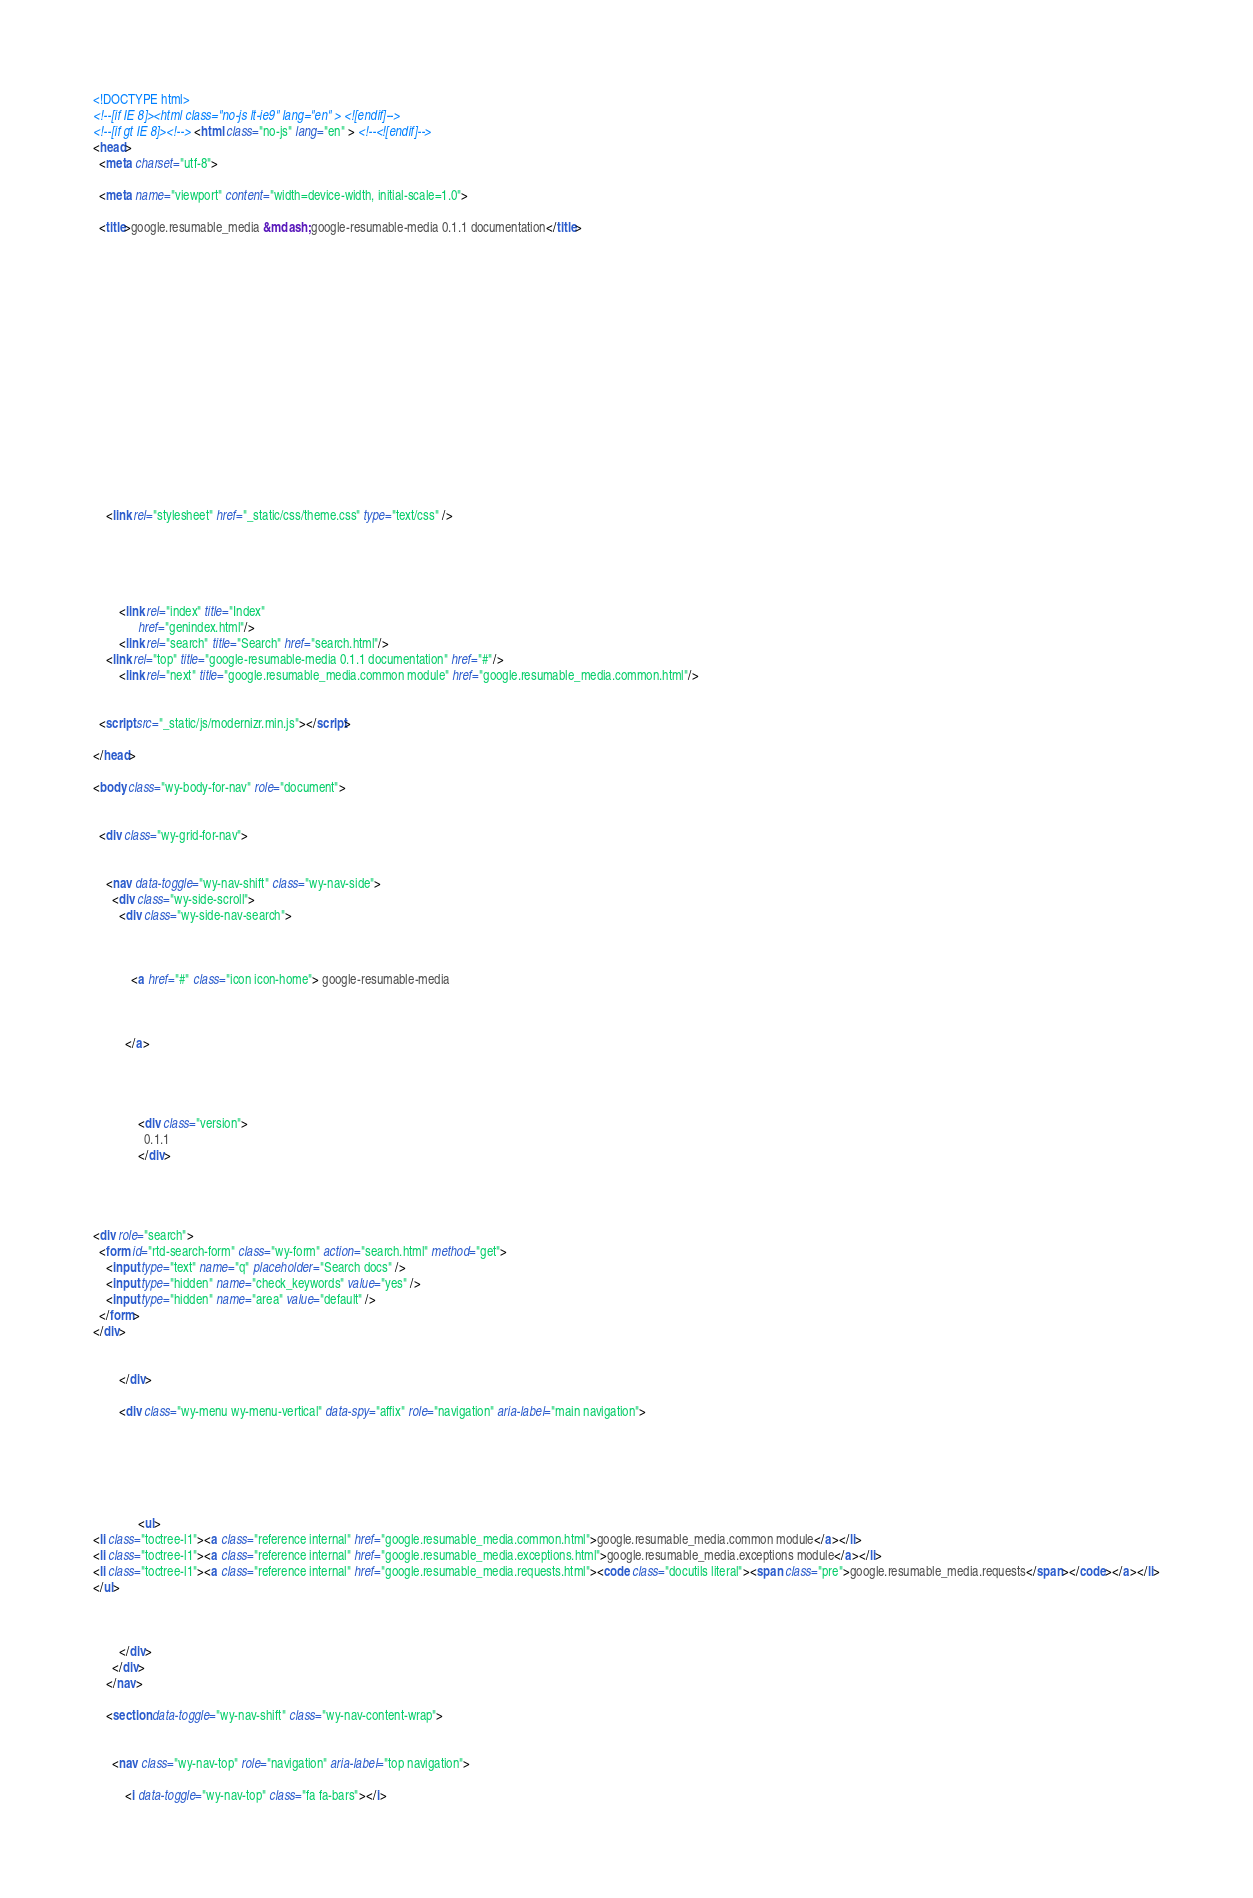Convert code to text. <code><loc_0><loc_0><loc_500><loc_500><_HTML_>

<!DOCTYPE html>
<!--[if IE 8]><html class="no-js lt-ie9" lang="en" > <![endif]-->
<!--[if gt IE 8]><!--> <html class="no-js" lang="en" > <!--<![endif]-->
<head>
  <meta charset="utf-8">
  
  <meta name="viewport" content="width=device-width, initial-scale=1.0">
  
  <title>google.resumable_media &mdash; google-resumable-media 0.1.1 documentation</title>
  

  
  
  
  

  

  
  
    

  

  
  
    <link rel="stylesheet" href="_static/css/theme.css" type="text/css" />
  

  

  
        <link rel="index" title="Index"
              href="genindex.html"/>
        <link rel="search" title="Search" href="search.html"/>
    <link rel="top" title="google-resumable-media 0.1.1 documentation" href="#"/>
        <link rel="next" title="google.resumable_media.common module" href="google.resumable_media.common.html"/> 

  
  <script src="_static/js/modernizr.min.js"></script>

</head>

<body class="wy-body-for-nav" role="document">

   
  <div class="wy-grid-for-nav">

    
    <nav data-toggle="wy-nav-shift" class="wy-nav-side">
      <div class="wy-side-scroll">
        <div class="wy-side-nav-search">
          

          
            <a href="#" class="icon icon-home"> google-resumable-media
          

          
          </a>

          
            
            
              <div class="version">
                0.1.1
              </div>
            
          

          
<div role="search">
  <form id="rtd-search-form" class="wy-form" action="search.html" method="get">
    <input type="text" name="q" placeholder="Search docs" />
    <input type="hidden" name="check_keywords" value="yes" />
    <input type="hidden" name="area" value="default" />
  </form>
</div>

          
        </div>

        <div class="wy-menu wy-menu-vertical" data-spy="affix" role="navigation" aria-label="main navigation">
          
            
            
              
            
            
              <ul>
<li class="toctree-l1"><a class="reference internal" href="google.resumable_media.common.html">google.resumable_media.common module</a></li>
<li class="toctree-l1"><a class="reference internal" href="google.resumable_media.exceptions.html">google.resumable_media.exceptions module</a></li>
<li class="toctree-l1"><a class="reference internal" href="google.resumable_media.requests.html"><code class="docutils literal"><span class="pre">google.resumable_media.requests</span></code></a></li>
</ul>

            
          
        </div>
      </div>
    </nav>

    <section data-toggle="wy-nav-shift" class="wy-nav-content-wrap">

      
      <nav class="wy-nav-top" role="navigation" aria-label="top navigation">
        
          <i data-toggle="wy-nav-top" class="fa fa-bars"></i></code> 